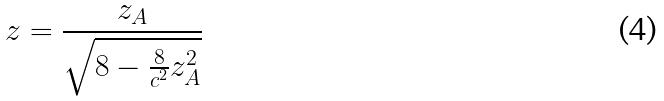Convert formula to latex. <formula><loc_0><loc_0><loc_500><loc_500>z = \frac { z _ { A } } { \sqrt { 8 - \frac { 8 } { c ^ { 2 } } z _ { A } ^ { 2 } } }</formula> 